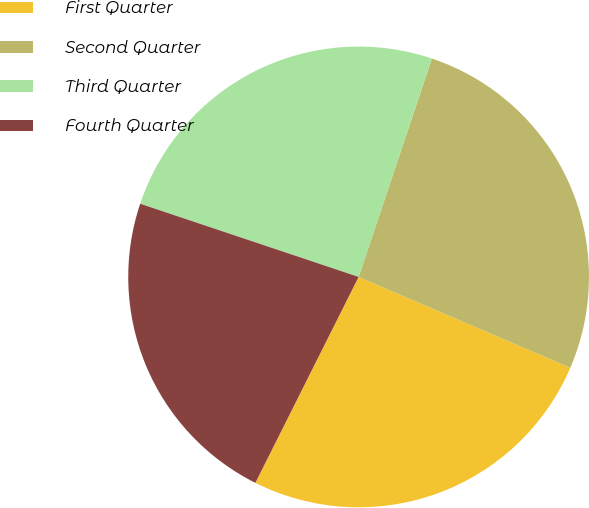Convert chart. <chart><loc_0><loc_0><loc_500><loc_500><pie_chart><fcel>First Quarter<fcel>Second Quarter<fcel>Third Quarter<fcel>Fourth Quarter<nl><fcel>25.95%<fcel>26.3%<fcel>25.01%<fcel>22.75%<nl></chart> 